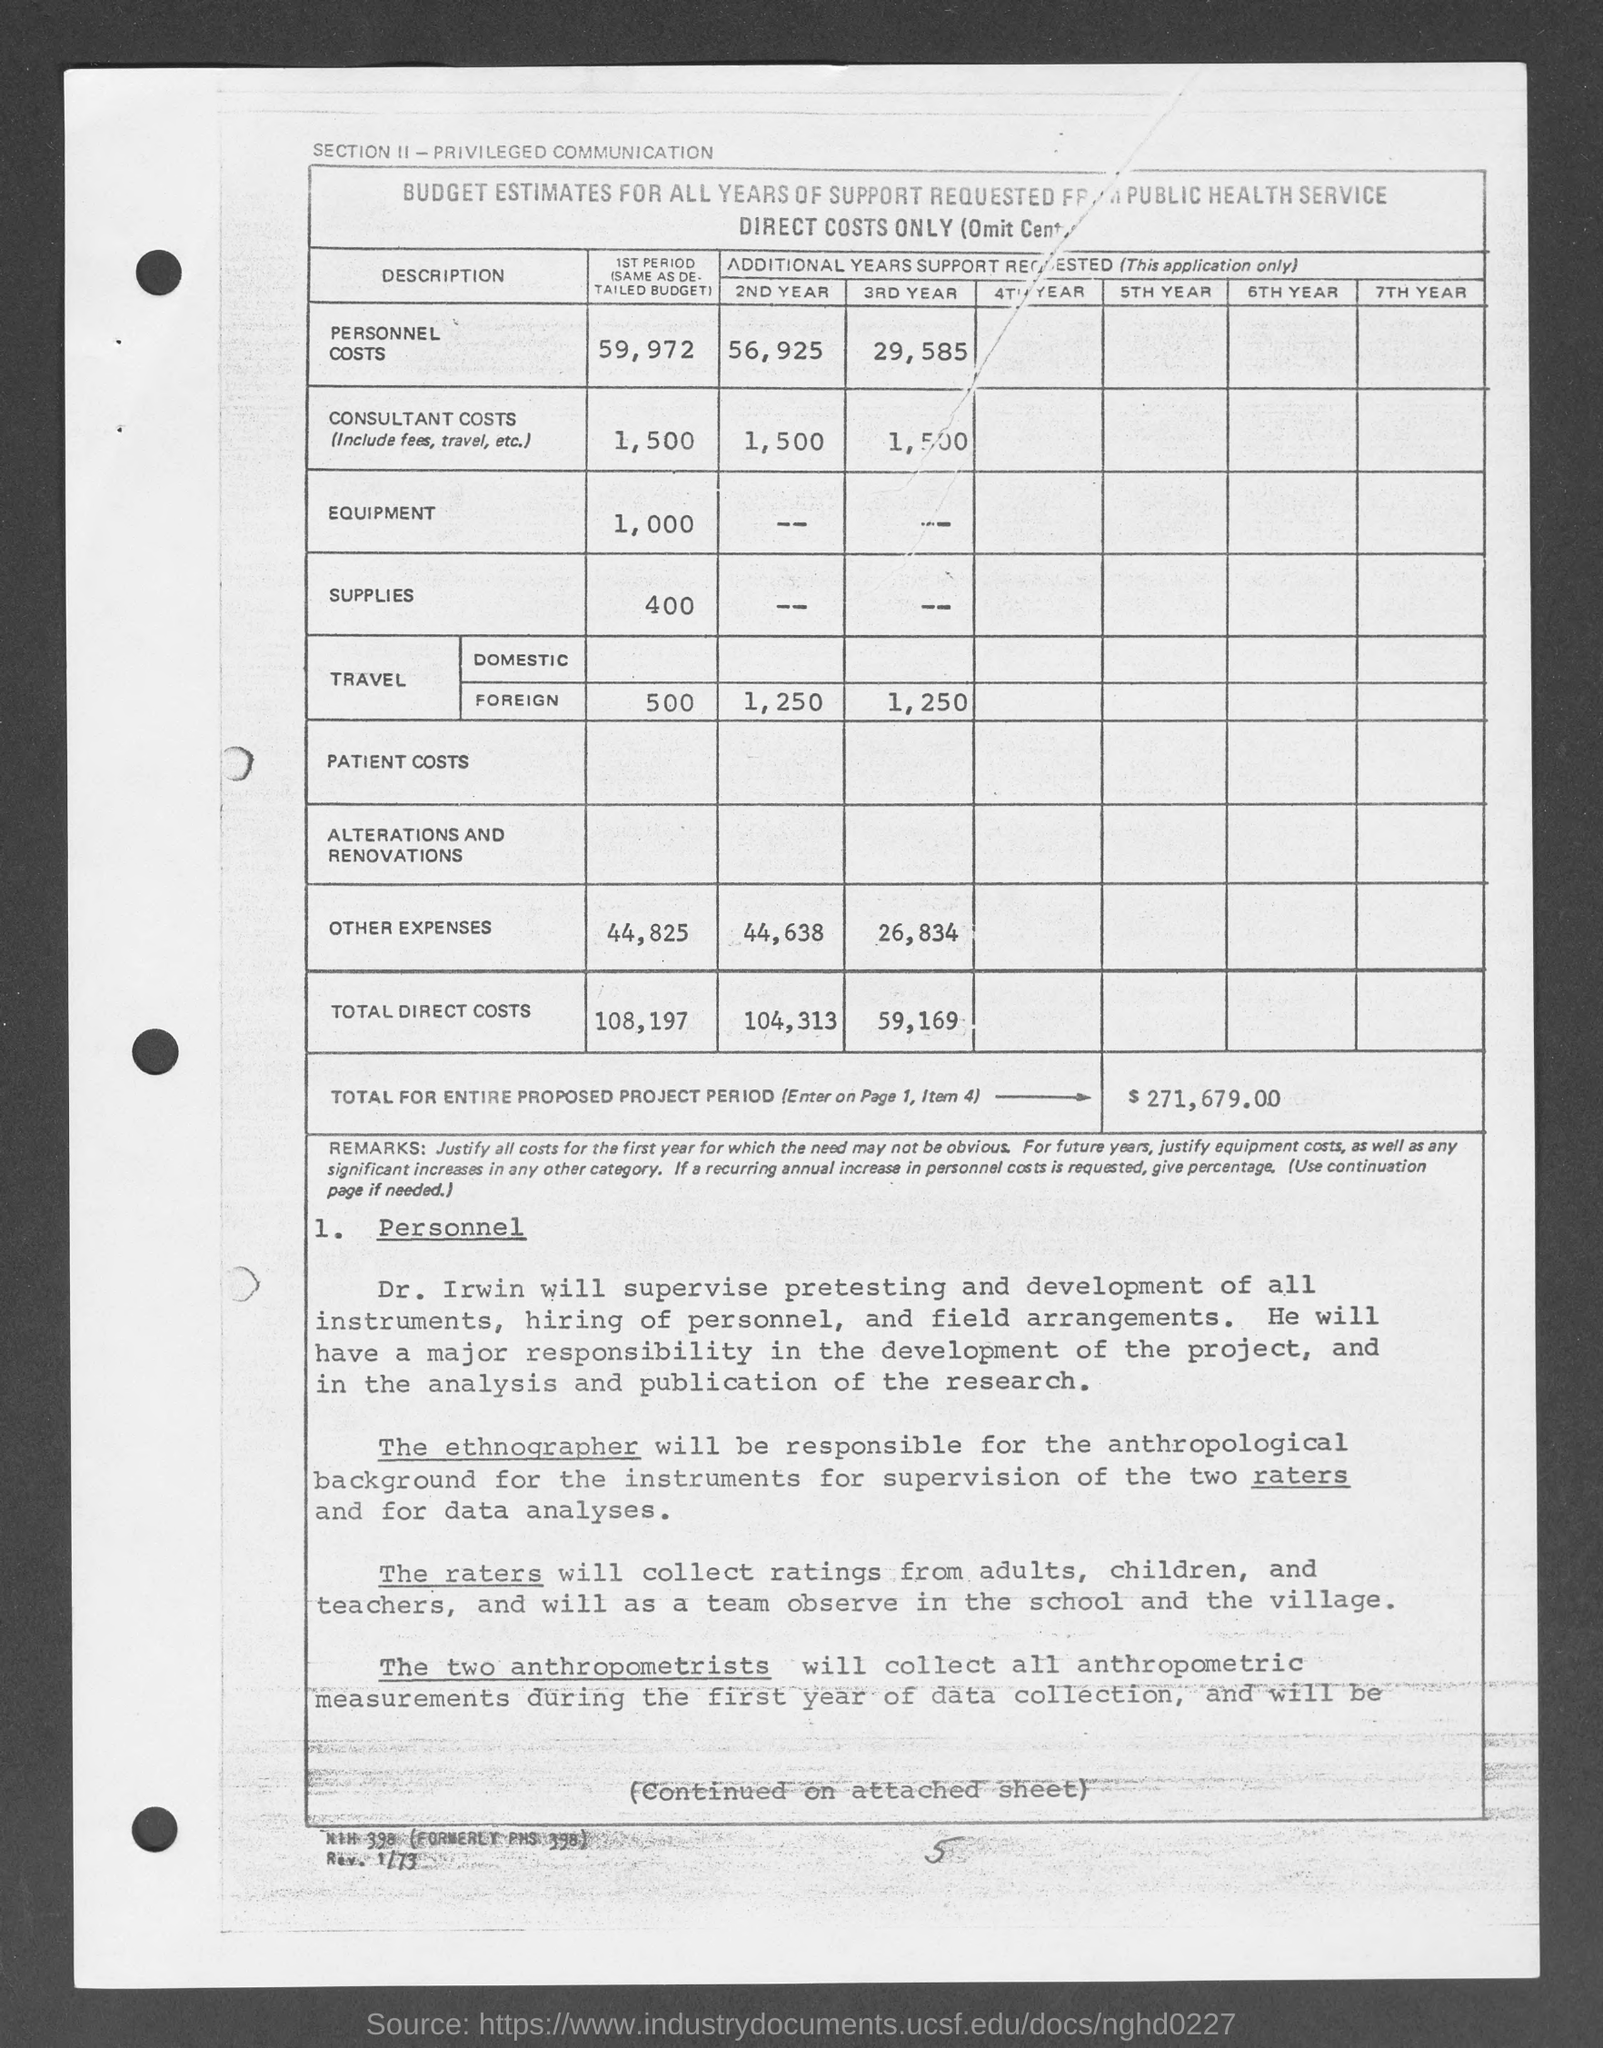Identify some key points in this picture. The amount for foreign travel during the second year mentioned in the given page is 1,250. The entire proposed project period is $271,679.00. The amount of supplies during the first period, as mentioned on the given page, is 400. The estimated amount of budget for equipment during the first period is 1,000. The amount of other expenses during the second year is 44,638. 